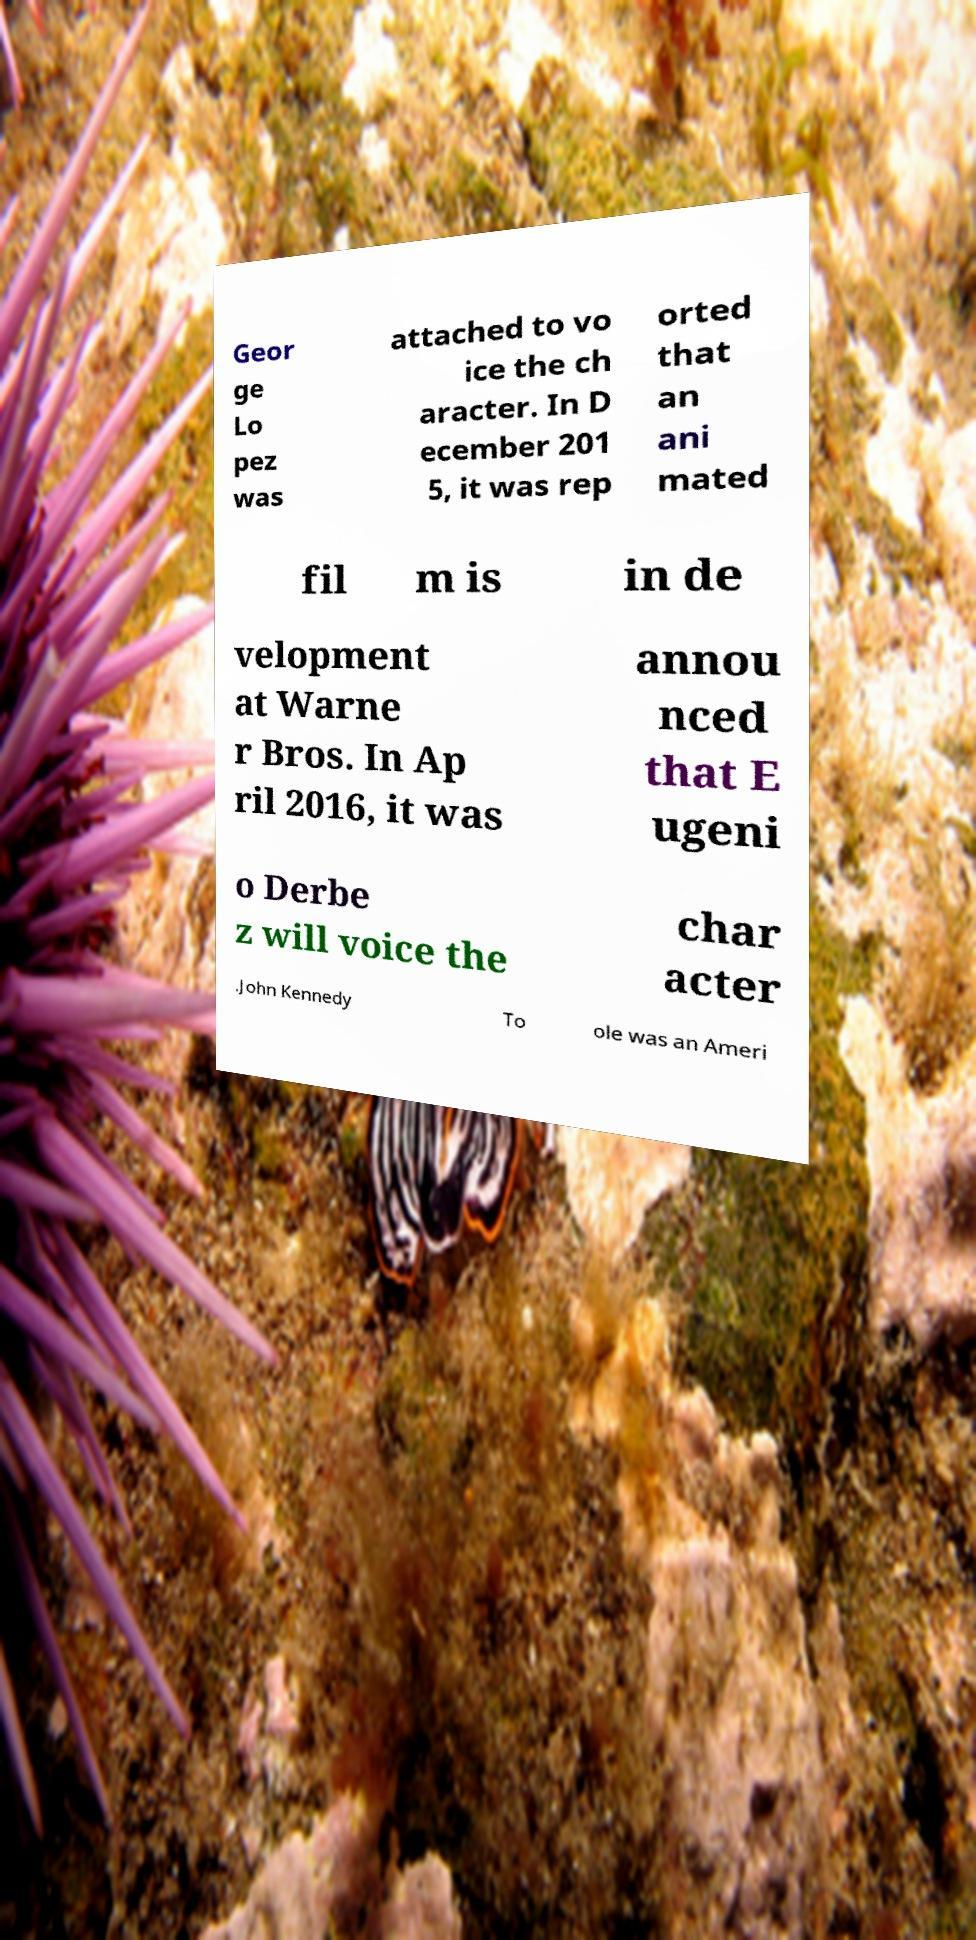There's text embedded in this image that I need extracted. Can you transcribe it verbatim? Geor ge Lo pez was attached to vo ice the ch aracter. In D ecember 201 5, it was rep orted that an ani mated fil m is in de velopment at Warne r Bros. In Ap ril 2016, it was annou nced that E ugeni o Derbe z will voice the char acter .John Kennedy To ole was an Ameri 